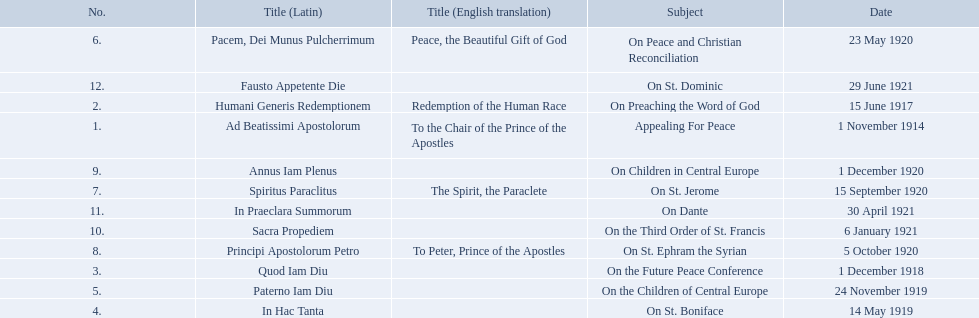What is the dates of the list of encyclicals of pope benedict xv? 1 November 1914, 15 June 1917, 1 December 1918, 14 May 1919, 24 November 1919, 23 May 1920, 15 September 1920, 5 October 1920, 1 December 1920, 6 January 1921, 30 April 1921, 29 June 1921. Of these dates, which subject was on 23 may 1920? On Peace and Christian Reconciliation. 